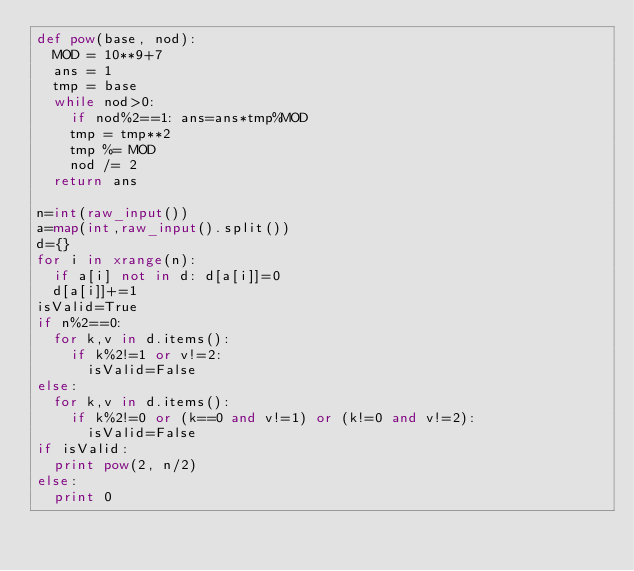Convert code to text. <code><loc_0><loc_0><loc_500><loc_500><_Python_>def pow(base, nod):
  MOD = 10**9+7
  ans = 1
  tmp = base
  while nod>0:
    if nod%2==1: ans=ans*tmp%MOD
    tmp = tmp**2
    tmp %= MOD
    nod /= 2
  return ans

n=int(raw_input())
a=map(int,raw_input().split())
d={}
for i in xrange(n):
  if a[i] not in d: d[a[i]]=0
  d[a[i]]+=1
isValid=True
if n%2==0:
  for k,v in d.items():
    if k%2!=1 or v!=2:
      isValid=False
else:
  for k,v in d.items():
    if k%2!=0 or (k==0 and v!=1) or (k!=0 and v!=2):
      isValid=False
if isValid:
  print pow(2, n/2)
else:
  print 0</code> 